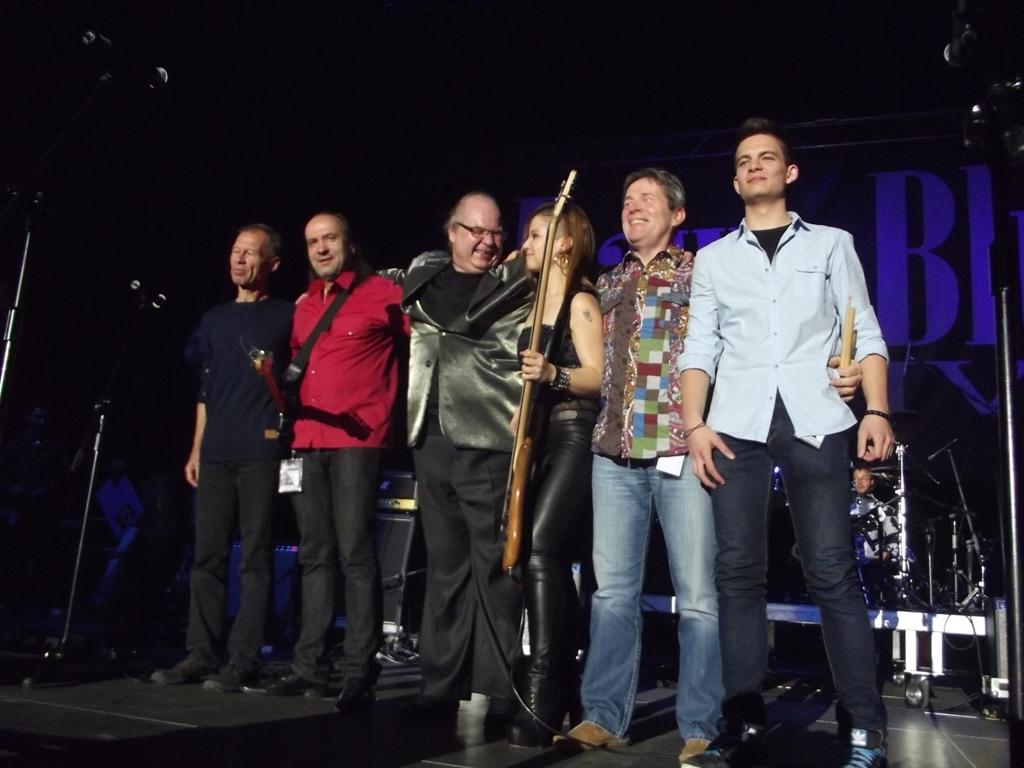How many people are present in the image? There are six people standing in the image. Where are the people standing? The people are standing on the floor. What object can be seen in the image that is typically used for amplifying sound? There is a microphone in the image. Is there any support for the microphone visible in the image? Yes, there is a stand associated with the microphone. What type of car is parked behind the people in the image? There is no car visible in the image; it only shows six people standing on the floor with a microphone and its stand. 